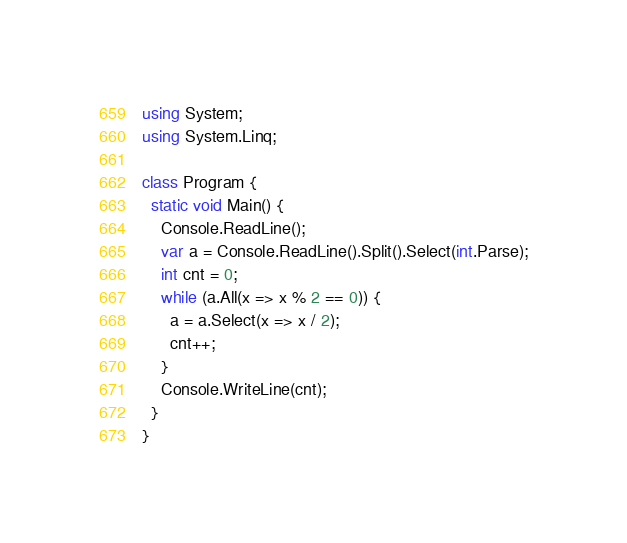<code> <loc_0><loc_0><loc_500><loc_500><_C#_>using System;
using System.Linq;

class Program {
  static void Main() {
    Console.ReadLine();
    var a = Console.ReadLine().Split().Select(int.Parse);
    int cnt = 0;
    while (a.All(x => x % 2 == 0)) {
      a = a.Select(x => x / 2);
      cnt++;
    }
    Console.WriteLine(cnt);
  }
}</code> 